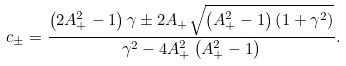Convert formula to latex. <formula><loc_0><loc_0><loc_500><loc_500>c _ { \pm } = \frac { \left ( 2 A _ { + } ^ { 2 } - 1 \right ) \gamma \pm 2 A _ { + } \sqrt { \left ( A _ { + } ^ { 2 } - 1 \right ) \left ( 1 + \gamma ^ { 2 } \right ) } } { \gamma ^ { 2 } - 4 A _ { + } ^ { 2 } \left ( A _ { + } ^ { 2 } - 1 \right ) } .</formula> 